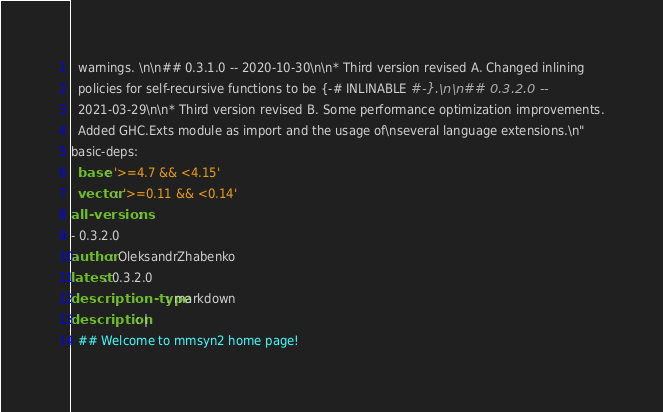Convert code to text. <code><loc_0><loc_0><loc_500><loc_500><_YAML_>  warnings. \n\n## 0.3.1.0 -- 2020-10-30\n\n* Third version revised A. Changed inlining
  policies for self-recursive functions to be {-# INLINABLE #-}.\n\n## 0.3.2.0 --
  2021-03-29\n\n* Third version revised B. Some performance optimization improvements.
  Added GHC.Exts module as import and the usage of\nseveral language extensions.\n"
basic-deps:
  base: '>=4.7 && <4.15'
  vector: '>=0.11 && <0.14'
all-versions:
- 0.3.2.0
author: OleksandrZhabenko
latest: 0.3.2.0
description-type: markdown
description: |
  ## Welcome to mmsyn2 home page!
</code> 